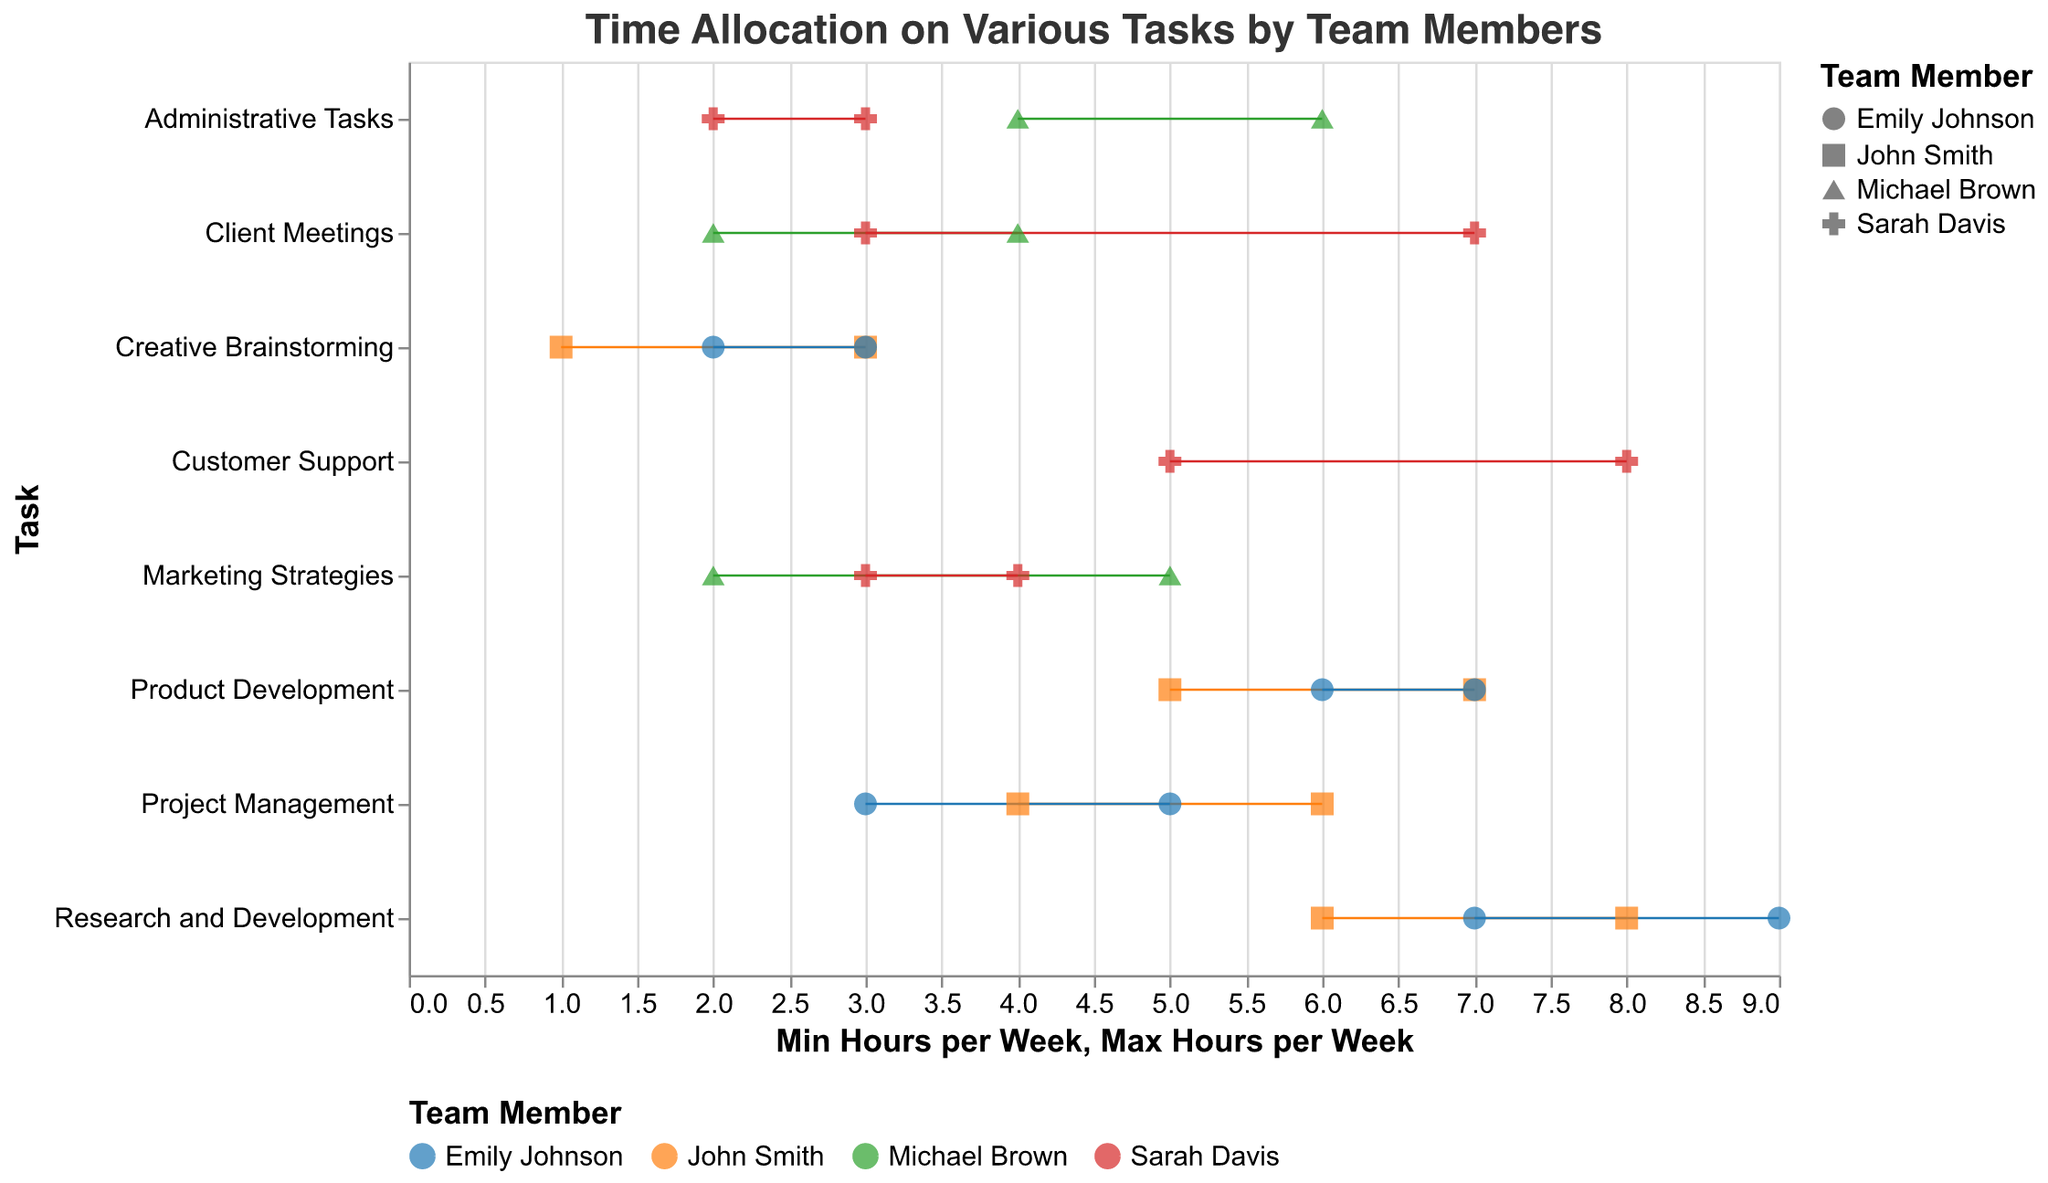What is the title of the chart? The title of the chart is found at the top and usually gives a summary of the visual data. In this case, the title is "Time Allocation on Various Tasks by Team Members".
Answer: Time Allocation on Various Tasks by Team Members How many team members are represented in the chart? By examining the legend and the data points, we can see that the team members represented are John Smith, Emily Johnson, Michael Brown, and Sarah Davis.
Answer: 4 Which team member spends the most time on Customer Support? By looking at the data points for the task "Customer Support", we see that Sarah Davis spends between 5 to 8 hours, and no other team member is listed for this task.
Answer: Sarah Davis On which task does John Smith spend the least amount of minimum hours per week? Examine the minimum hours per week for tasks assigned to John Smith. He spends the least amount of time on the task "Creative Brainstorming" with 1 hour per week as the minimum.
Answer: Creative Brainstorming What is the range of hours Emily Johnson spends on Research and Development? The range is calculated by subtracting the minimum hours from the maximum hours. For Emily Johnson, the minimum is 7 and the maximum is 9 hours for Research and Development. Hence, 9 - 7 = 2 hours.
Answer: 2 hours Compare the maximum hours spent on Administrative Tasks by Michael Brown and Sarah Davis. Who spends more? Michael Brown spends a maximum of 6 hours, whereas Sarah Davis spends a maximum of 3 hours on Administrative Tasks. Hence, Michael Brown spends more.
Answer: Michael Brown Between Sarah Davis and Michael Brown, who allocates more time to Client Meetings on average? Calculate the average by adding the minimum and maximum and dividing by 2. For Sarah, (3 + 7)/2 = 5, for Michael, (2 + 4)/2 = 3. Hence, Sarah allocates more time on average.
Answer: Sarah Davis Which tasks have the largest range of hours for time allocation? To find the largest range, subtract the minimum from the maximum for each task. "Client Meetings" for Sarah Davis has the largest range of 4 hours, from 3 to 7 hours.
Answer: Client Meetings (Sarah Davis) Which task has the minimum variance in time allocation across all tasks and team members? Variance can be visually inferred by looking for consistently short lines for all team members within a task. "Creative Brainstorming" has the least variance as the ranges are between 1-3 and 2-3.
Answer: Creative Brainstorming 